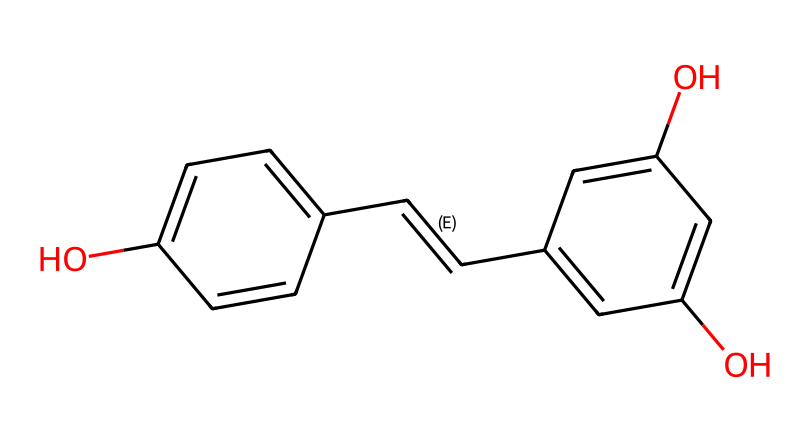What is the name of this chemical? The SMILES representation indicates the chemical structure of resveratrol, which is a well-known polyphenolic antioxidant found in red wine.
Answer: resveratrol How many hydroxyl (OH) groups are present? By analyzing the chemical structure, there are three hydroxyl groups (indicated by the "O" atoms bonded to the phenolic rings).
Answer: three What is the total number of carbon atoms in the structure? Counting the carbon atoms, there are 14 carbon atoms in the structure (6 from each of the two phenolic rings and 2 from the double bond in between, plus 2 from the connecting carbon atoms).
Answer: fourteen Is this compound a simple phenolic or a polyphenolic? The presence of two phenolic units in the chemical structure classifies it as polyphenolic.
Answer: polyphenolic What type of bonding is predominantly found in this molecule? The SMILES representation shows a mix of single and double bonds, but the predominant type of bonding is single covalent bonds connecting the carbon and hydroxyl groups.
Answer: covalent What functional groups are present in this compound? The presence of hydroxyl groups indicates that the functional groups in this compound are phenolic and alcoholic in nature.
Answer: hydroxyl groups What type of antioxidant activity does this compound exhibit? Resveratrol exhibits notable scavenging activity against free radicals due to its ability to donate hydrogen atoms from its hydroxyl groups.
Answer: free radical scavenger 